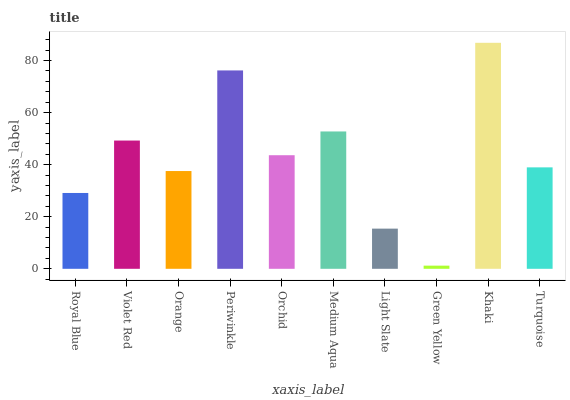Is Green Yellow the minimum?
Answer yes or no. Yes. Is Khaki the maximum?
Answer yes or no. Yes. Is Violet Red the minimum?
Answer yes or no. No. Is Violet Red the maximum?
Answer yes or no. No. Is Violet Red greater than Royal Blue?
Answer yes or no. Yes. Is Royal Blue less than Violet Red?
Answer yes or no. Yes. Is Royal Blue greater than Violet Red?
Answer yes or no. No. Is Violet Red less than Royal Blue?
Answer yes or no. No. Is Orchid the high median?
Answer yes or no. Yes. Is Turquoise the low median?
Answer yes or no. Yes. Is Medium Aqua the high median?
Answer yes or no. No. Is Royal Blue the low median?
Answer yes or no. No. 